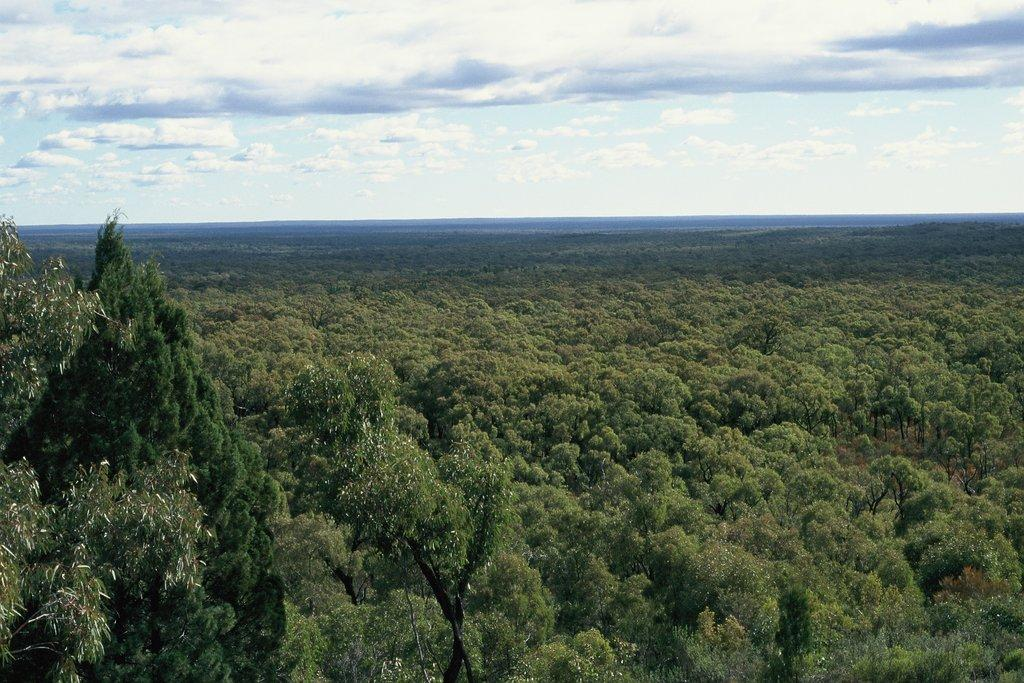What is the main subject of the image? There is a large group of trees in the image. What else can be seen in the image besides the trees? The sky is visible in the image. How would you describe the sky in the image? The sky appears to be cloudy. How many notes are attached to the clam in the image? There is no clam or notes present in the image; it only features a large group of trees and a cloudy sky. 